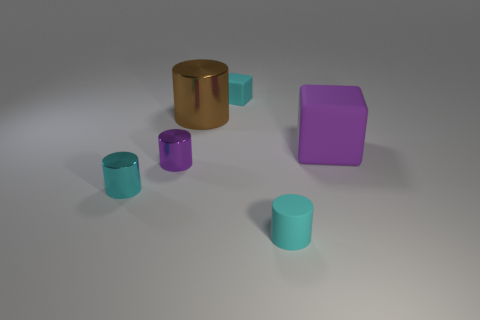What time of day does the lighting suggest? The soft, diffuse shadows and the overall tone of the lighting suggest an indoor environment, possibly lit by ambient, artificial light without a strong indication of a particular time of day. 